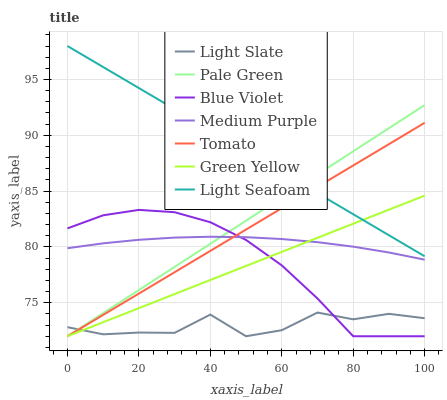Does Light Slate have the minimum area under the curve?
Answer yes or no. Yes. Does Light Seafoam have the maximum area under the curve?
Answer yes or no. Yes. Does Light Seafoam have the minimum area under the curve?
Answer yes or no. No. Does Light Slate have the maximum area under the curve?
Answer yes or no. No. Is Green Yellow the smoothest?
Answer yes or no. Yes. Is Light Slate the roughest?
Answer yes or no. Yes. Is Light Seafoam the smoothest?
Answer yes or no. No. Is Light Seafoam the roughest?
Answer yes or no. No. Does Tomato have the lowest value?
Answer yes or no. Yes. Does Light Seafoam have the lowest value?
Answer yes or no. No. Does Light Seafoam have the highest value?
Answer yes or no. Yes. Does Light Slate have the highest value?
Answer yes or no. No. Is Light Slate less than Light Seafoam?
Answer yes or no. Yes. Is Light Seafoam greater than Medium Purple?
Answer yes or no. Yes. Does Tomato intersect Blue Violet?
Answer yes or no. Yes. Is Tomato less than Blue Violet?
Answer yes or no. No. Is Tomato greater than Blue Violet?
Answer yes or no. No. Does Light Slate intersect Light Seafoam?
Answer yes or no. No. 